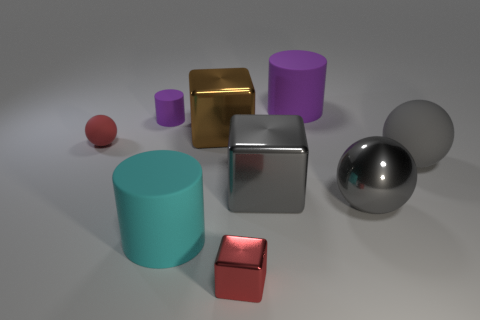Subtract all large cubes. How many cubes are left? 1 Add 1 tiny blocks. How many objects exist? 10 Subtract all brown cubes. How many cubes are left? 2 Subtract 1 spheres. How many spheres are left? 2 Subtract all balls. How many objects are left? 6 Add 2 red blocks. How many red blocks are left? 3 Add 2 big blue matte objects. How many big blue matte objects exist? 2 Subtract 1 cyan cylinders. How many objects are left? 8 Subtract all red cylinders. Subtract all green balls. How many cylinders are left? 3 Subtract all blue balls. How many brown blocks are left? 1 